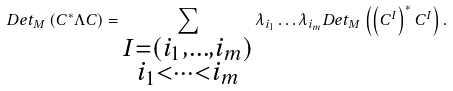Convert formula to latex. <formula><loc_0><loc_0><loc_500><loc_500>D e t _ { M } \left ( C ^ { \ast } \Lambda C \right ) = \sum _ { \substack { I = \left ( i _ { 1 } , \dots , i _ { m } \right ) \\ i _ { 1 } < \dots < i _ { m } } } \lambda _ { i _ { 1 } } \dots \lambda _ { i _ { m } } D e t _ { M } \left ( \left ( C ^ { I } \right ) ^ { \ast } C ^ { I } \right ) .</formula> 